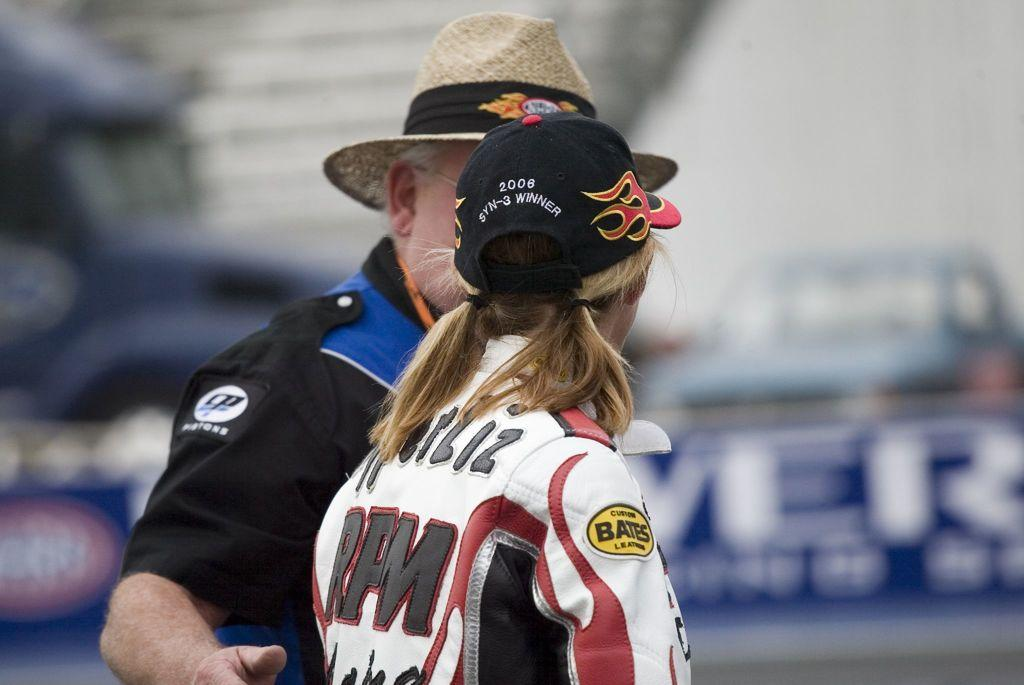<image>
Describe the image concisely. a lady with RFM on her jacket she is wearing 